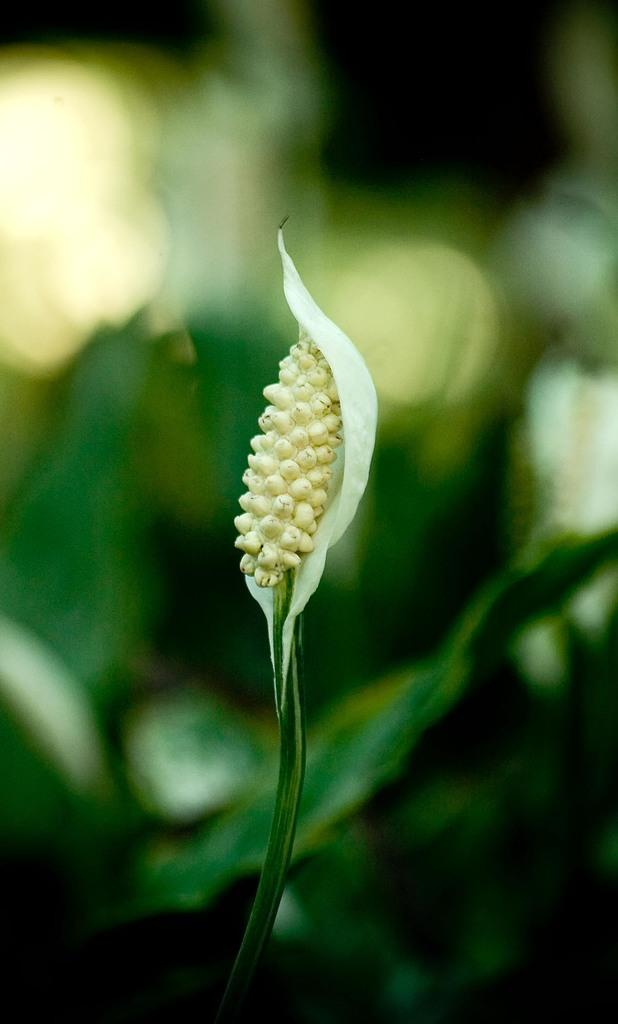What is the main subject of the image? There is a flower in the middle of the image. Can you describe the background of the image? The background of the image is blurred. What type of rhythm does the queen dance to in the image? There is no queen or dancing present in the image; it features a flower with a blurred background. 